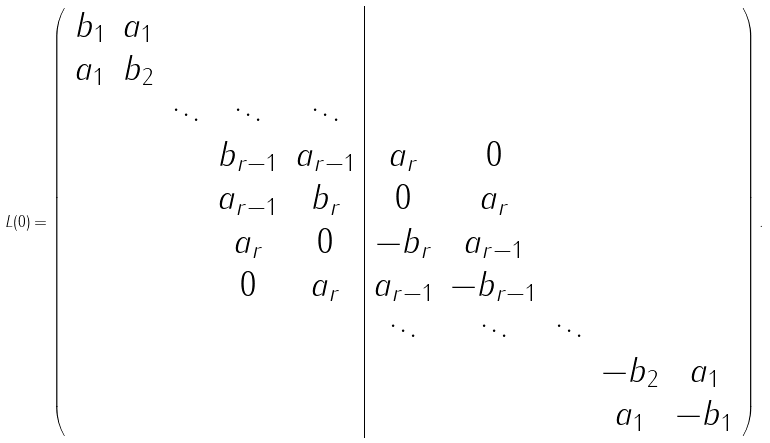Convert formula to latex. <formula><loc_0><loc_0><loc_500><loc_500>L ( 0 ) = \left ( \begin{array} { c c c c c | c c c c c } b _ { 1 } & a _ { 1 } & & & & & & & & \\ a _ { 1 } & b _ { 2 } & & & & & & & & \\ & & \ddots & \ddots & \ddots & & & & & \\ & & & b _ { r - 1 } & a _ { r - 1 } & a _ { r } & 0 & & & \\ & & & a _ { r - 1 } & b _ { r } & 0 & a _ { r } & & & \\ & & & a _ { r } & 0 & - b _ { r } & a _ { r - 1 } & & & \\ & & & 0 & a _ { r } & a _ { r - 1 } & - b _ { r - 1 } & & & \\ & & & & & \ddots & \ddots & \ddots & & \\ & & & & & & & & - b _ { 2 } & a _ { 1 } \\ & & & & & & & & a _ { 1 } & - b _ { 1 } \end{array} \right ) .</formula> 